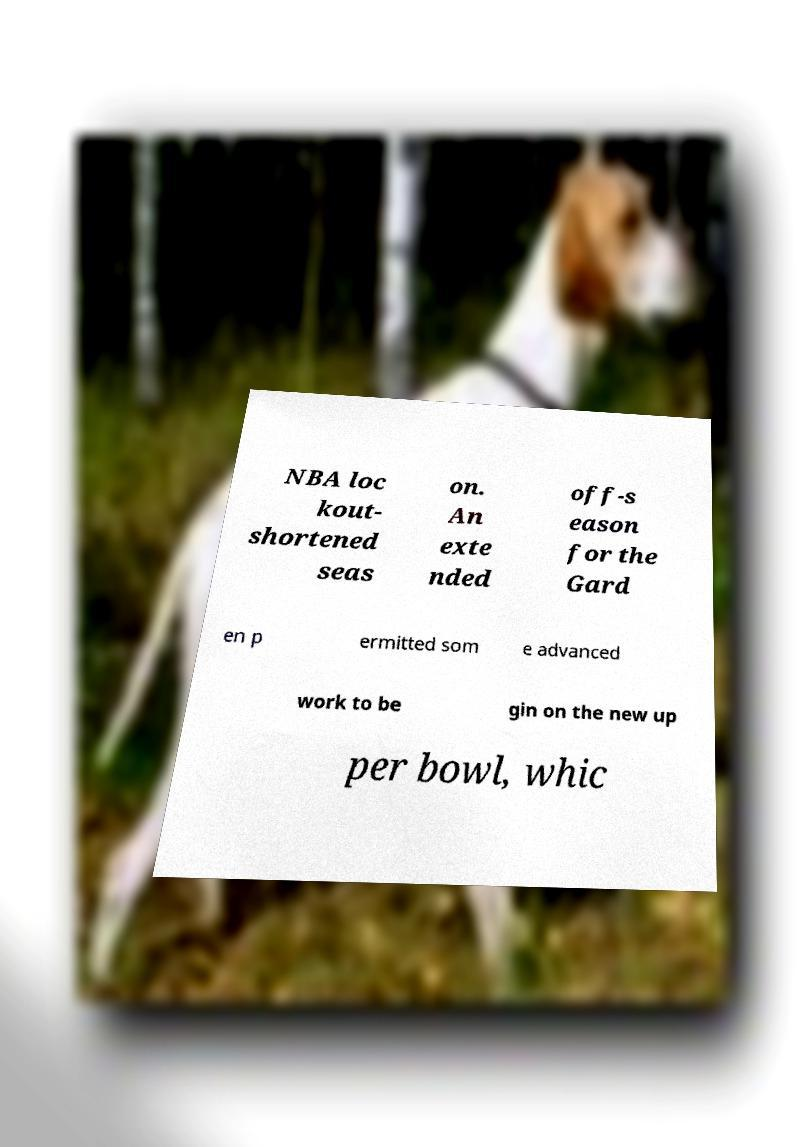Could you extract and type out the text from this image? NBA loc kout- shortened seas on. An exte nded off-s eason for the Gard en p ermitted som e advanced work to be gin on the new up per bowl, whic 